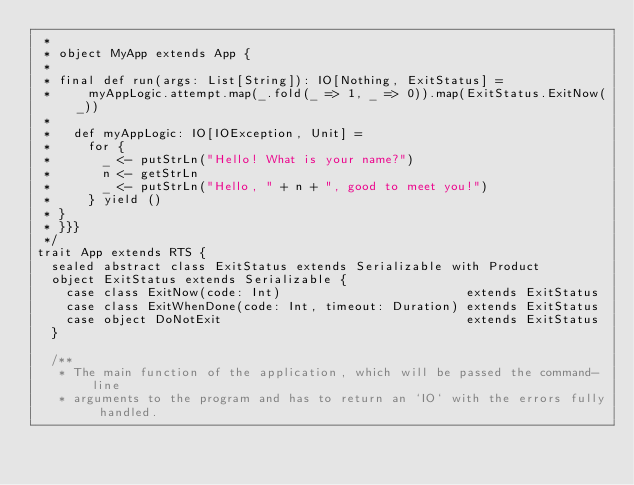<code> <loc_0><loc_0><loc_500><loc_500><_Scala_> *
 * object MyApp extends App {
 *
 * final def run(args: List[String]): IO[Nothing, ExitStatus] =
 *     myAppLogic.attempt.map(_.fold(_ => 1, _ => 0)).map(ExitStatus.ExitNow(_))
 *
 *   def myAppLogic: IO[IOException, Unit] =
 *     for {
 *       _ <- putStrLn("Hello! What is your name?")
 *       n <- getStrLn
 *       _ <- putStrLn("Hello, " + n + ", good to meet you!")
 *     } yield ()
 * }
 * }}}
 */
trait App extends RTS {
  sealed abstract class ExitStatus extends Serializable with Product
  object ExitStatus extends Serializable {
    case class ExitNow(code: Int)                         extends ExitStatus
    case class ExitWhenDone(code: Int, timeout: Duration) extends ExitStatus
    case object DoNotExit                                 extends ExitStatus
  }

  /**
   * The main function of the application, which will be passed the command-line
   * arguments to the program and has to return an `IO` with the errors fully handled.</code> 